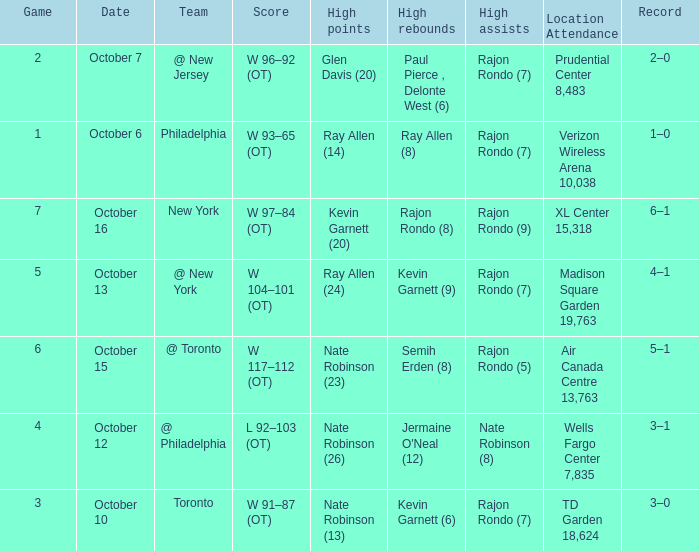Who had the most assists and how many did they have on October 7?  Rajon Rondo (7). 